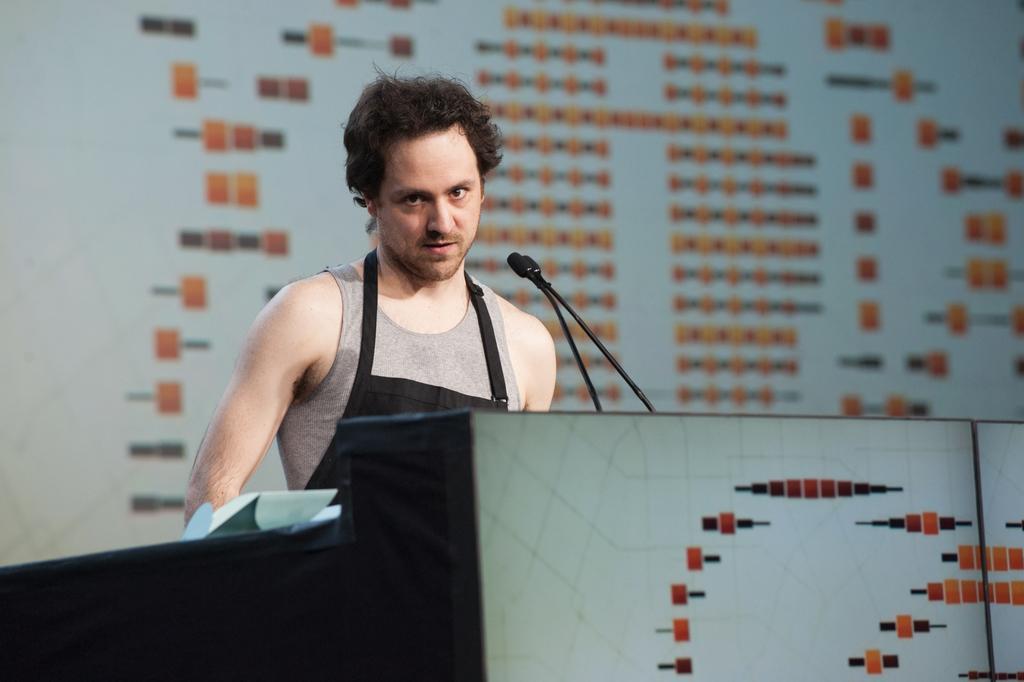Can you describe this image briefly? In this image there is a person behind the podium having a mike, papers. Background there is a wall. 